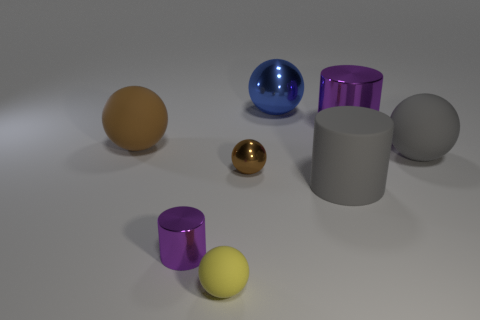Subtract all blue spheres. How many spheres are left? 4 Subtract all small brown balls. How many balls are left? 4 Add 1 green matte cubes. How many objects exist? 9 Subtract all red balls. Subtract all yellow blocks. How many balls are left? 5 Subtract all cylinders. How many objects are left? 5 Subtract 0 blue cylinders. How many objects are left? 8 Subtract all yellow blocks. Subtract all purple cylinders. How many objects are left? 6 Add 3 small objects. How many small objects are left? 6 Add 1 blue spheres. How many blue spheres exist? 2 